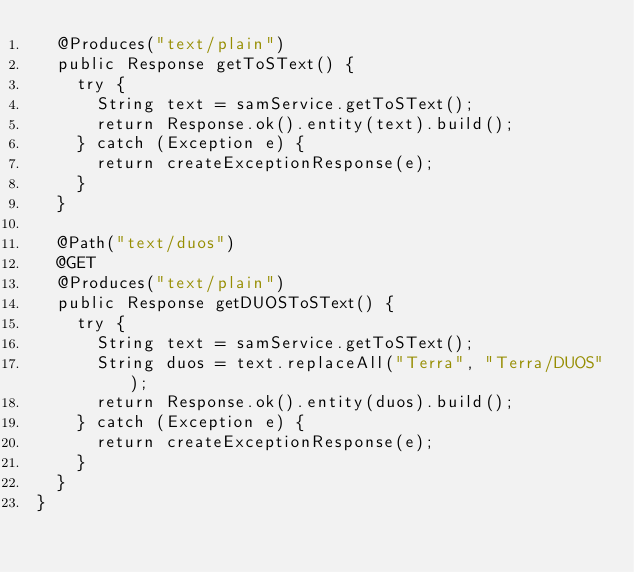Convert code to text. <code><loc_0><loc_0><loc_500><loc_500><_Java_>  @Produces("text/plain")
  public Response getToSText() {
    try {
      String text = samService.getToSText();
      return Response.ok().entity(text).build();
    } catch (Exception e) {
      return createExceptionResponse(e);
    }
  }

  @Path("text/duos")
  @GET
  @Produces("text/plain")
  public Response getDUOSToSText() {
    try {
      String text = samService.getToSText();
      String duos = text.replaceAll("Terra", "Terra/DUOS");
      return Response.ok().entity(duos).build();
    } catch (Exception e) {
      return createExceptionResponse(e);
    }
  }
}
</code> 